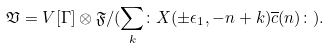<formula> <loc_0><loc_0><loc_500><loc_500>\mathfrak V = V [ \Gamma ] \otimes \mathfrak { F } / ( \sum _ { k } \colon X ( \pm \epsilon _ { 1 } , - n + k ) \overline { c } ( n ) \colon ) .</formula> 